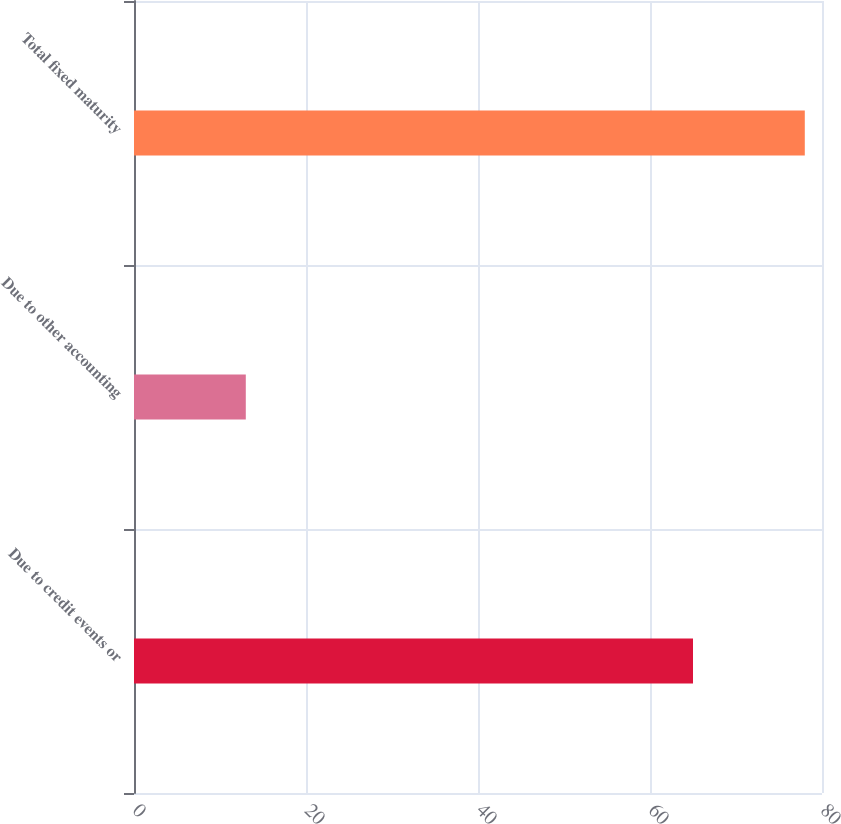Convert chart to OTSL. <chart><loc_0><loc_0><loc_500><loc_500><bar_chart><fcel>Due to credit events or<fcel>Due to other accounting<fcel>Total fixed maturity<nl><fcel>65<fcel>13<fcel>78<nl></chart> 